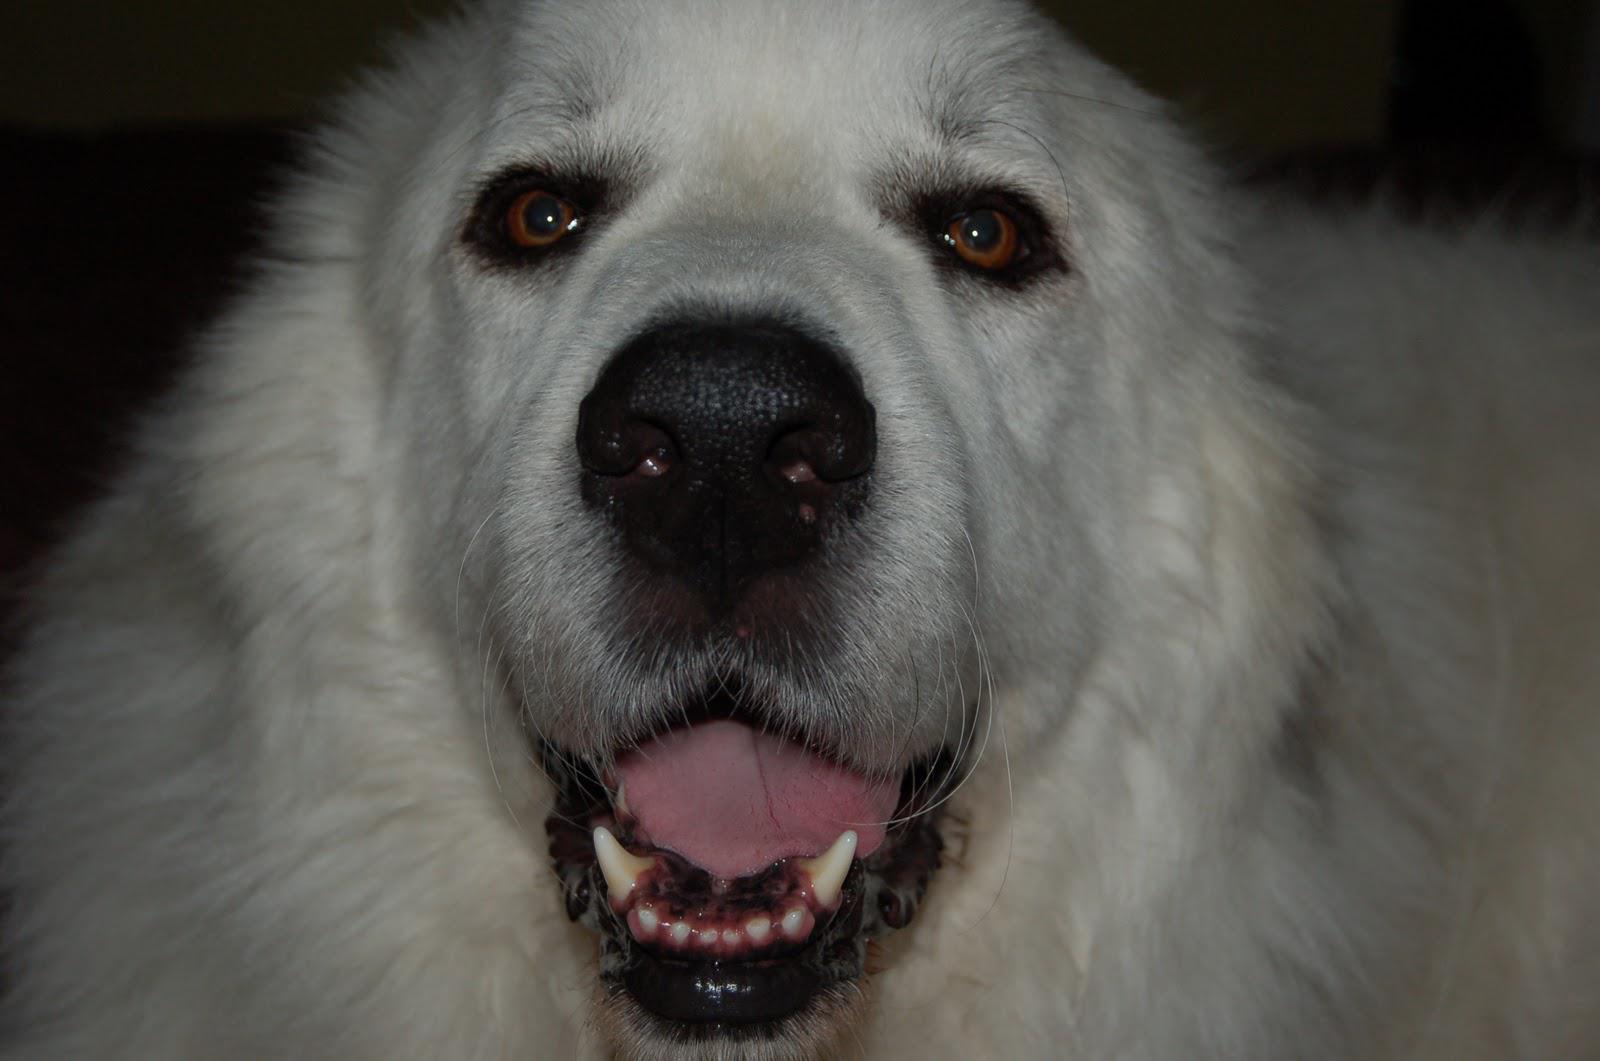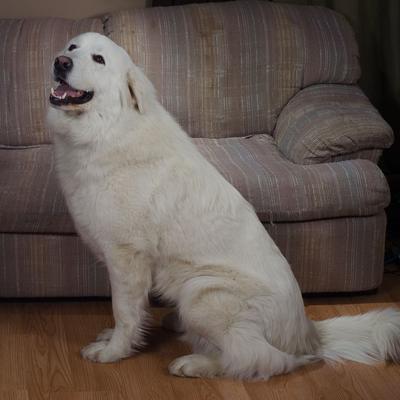The first image is the image on the left, the second image is the image on the right. Assess this claim about the two images: "One of the dogs is sitting in front of the sofa.". Correct or not? Answer yes or no. Yes. The first image is the image on the left, the second image is the image on the right. For the images shown, is this caption "There is a picture of the white dogs full body and not just his head." true? Answer yes or no. Yes. 